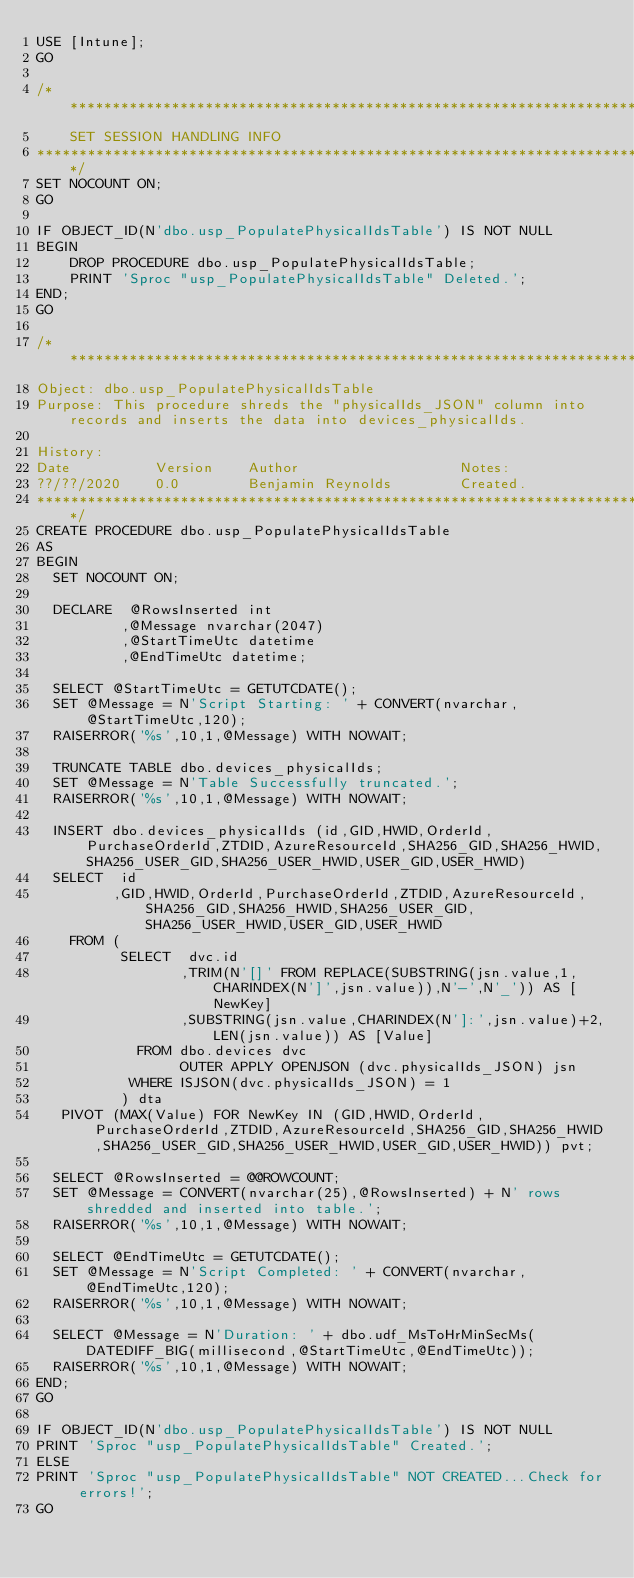<code> <loc_0><loc_0><loc_500><loc_500><_SQL_>USE [Intune];
GO

/********************************************************************************************
    SET SESSION HANDLING INFO
********************************************************************************************/
SET NOCOUNT ON;
GO

IF OBJECT_ID(N'dbo.usp_PopulatePhysicalIdsTable') IS NOT NULL
BEGIN
    DROP PROCEDURE dbo.usp_PopulatePhysicalIdsTable;
    PRINT 'Sproc "usp_PopulatePhysicalIdsTable" Deleted.';
END;
GO

/***************************************************************************************************************
Object: dbo.usp_PopulatePhysicalIdsTable
Purpose: This procedure shreds the "physicalIds_JSON" column into records and inserts the data into devices_physicalIds.

History:
Date          Version    Author                   Notes:
??/??/2020    0.0        Benjamin Reynolds        Created.
*****************************************************************************************************************/
CREATE PROCEDURE dbo.usp_PopulatePhysicalIdsTable
AS
BEGIN
  SET NOCOUNT ON;
  
  DECLARE  @RowsInserted int
          ,@Message nvarchar(2047)
          ,@StartTimeUtc datetime
          ,@EndTimeUtc datetime;

  SELECT @StartTimeUtc = GETUTCDATE();
  SET @Message = N'Script Starting: ' + CONVERT(nvarchar,@StartTimeUtc,120);
  RAISERROR('%s',10,1,@Message) WITH NOWAIT;
  
  TRUNCATE TABLE dbo.devices_physicalIds;
  SET @Message = N'Table Successfully truncated.';
  RAISERROR('%s',10,1,@Message) WITH NOWAIT;
  
  INSERT dbo.devices_physicalIds (id,GID,HWID,OrderId,PurchaseOrderId,ZTDID,AzureResourceId,SHA256_GID,SHA256_HWID,SHA256_USER_GID,SHA256_USER_HWID,USER_GID,USER_HWID)
  SELECT  id
         ,GID,HWID,OrderId,PurchaseOrderId,ZTDID,AzureResourceId,SHA256_GID,SHA256_HWID,SHA256_USER_GID,SHA256_USER_HWID,USER_GID,USER_HWID
    FROM (
          SELECT  dvc.id
                 ,TRIM(N'[]' FROM REPLACE(SUBSTRING(jsn.value,1,CHARINDEX(N']',jsn.value)),N'-',N'_')) AS [NewKey]
                 ,SUBSTRING(jsn.value,CHARINDEX(N']:',jsn.value)+2,LEN(jsn.value)) AS [Value]
            FROM dbo.devices dvc
                 OUTER APPLY OPENJSON (dvc.physicalIds_JSON) jsn
           WHERE ISJSON(dvc.physicalIds_JSON) = 1
          ) dta
   PIVOT (MAX(Value) FOR NewKey IN (GID,HWID,OrderId,PurchaseOrderId,ZTDID,AzureResourceId,SHA256_GID,SHA256_HWID,SHA256_USER_GID,SHA256_USER_HWID,USER_GID,USER_HWID)) pvt;
  
  SELECT @RowsInserted = @@ROWCOUNT;
  SET @Message = CONVERT(nvarchar(25),@RowsInserted) + N' rows shredded and inserted into table.';
  RAISERROR('%s',10,1,@Message) WITH NOWAIT;

  SELECT @EndTimeUtc = GETUTCDATE();
  SET @Message = N'Script Completed: ' + CONVERT(nvarchar,@EndTimeUtc,120);
  RAISERROR('%s',10,1,@Message) WITH NOWAIT;

  SELECT @Message = N'Duration: ' + dbo.udf_MsToHrMinSecMs(DATEDIFF_BIG(millisecond,@StartTimeUtc,@EndTimeUtc));
  RAISERROR('%s',10,1,@Message) WITH NOWAIT;
END;
GO

IF OBJECT_ID(N'dbo.usp_PopulatePhysicalIdsTable') IS NOT NULL
PRINT 'Sproc "usp_PopulatePhysicalIdsTable" Created.';
ELSE
PRINT 'Sproc "usp_PopulatePhysicalIdsTable" NOT CREATED...Check for errors!';
GO</code> 